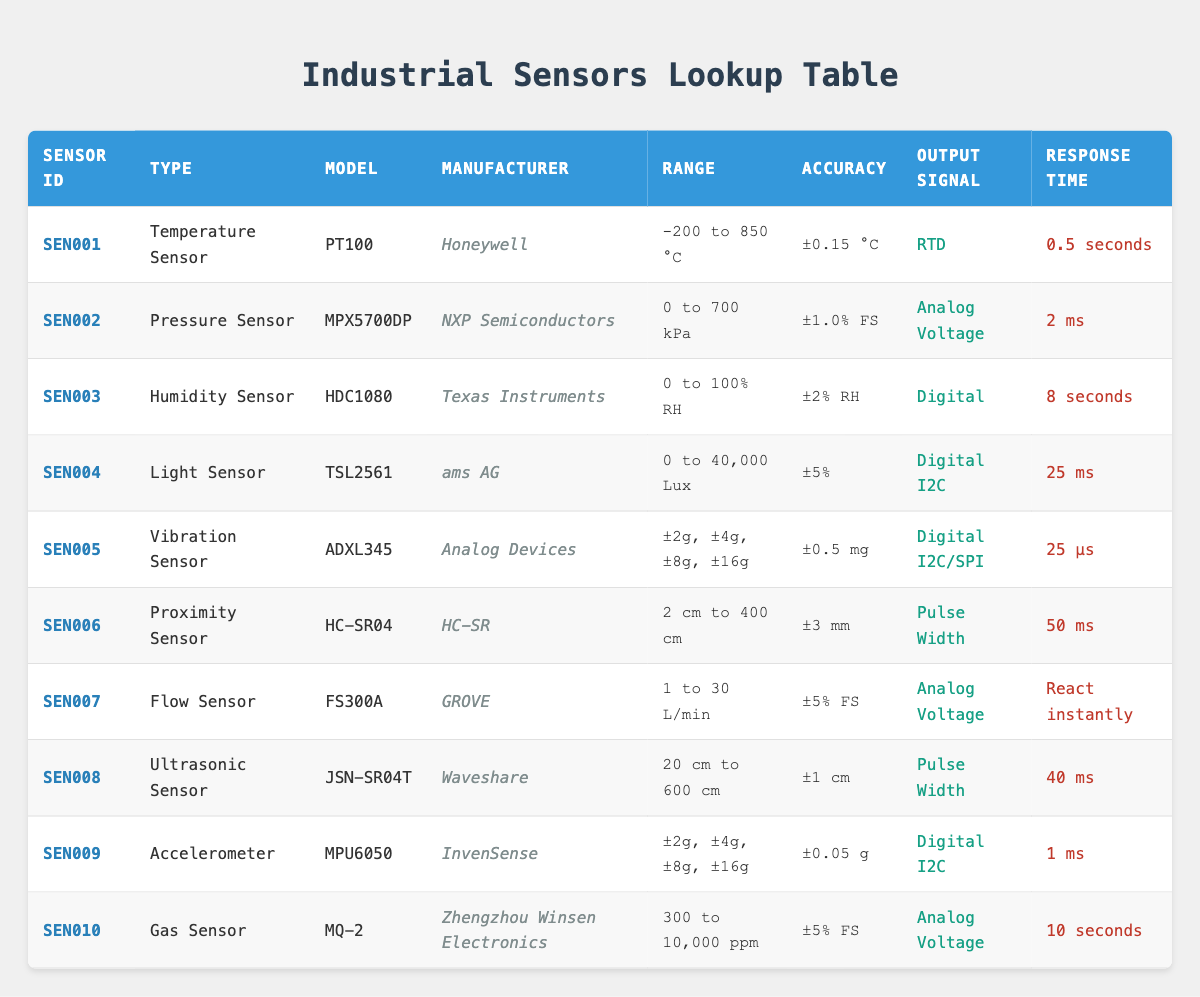What is the model of the temperature sensor? The table lists the temperature sensor under "Type" as "Temperature Sensor" and specifies the model in the column labeled "Model." Therefore, looking under that column for "SEN001," we find that the model is "PT100."
Answer: PT100 Which sensor has the highest range measured in Lux? To find out which sensor has the highest range measured in Lux, we look at the "Range" column for sensors that are light sensors. The only sensor in that category is "TSL2561," which has a range of "0 to 40,000 Lux."
Answer: TSL2561 What is the response time of the vibration sensor? The vibration sensor is listed under "SEN005." Looking across that row, we can see the "Response Time" column states it takes "25 µs."
Answer: 25 µs Do all the sensors listed have an accuracy value? We can review each row in the "Accuracy" column to see if any sensors lack an accuracy value. All listed sensors show an accuracy value, confirming that each one has this specification.
Answer: Yes What is the average range of the pressure sensor and the gas sensor in kPa and ppm? The pressure sensor (SEN002) has a range of "0 to 700 kPa," and the gas sensor (SEN010) has "300 to 10,000 ppm." To calculate average values for both, we consider the upper limits: 700 kPa and 10,000 ppm. The average range is (700 + 10000) / 2 considering only the upper limits: 5,350. The ranges technically are in different units, making their average comparison inapplicable in direct terms; this shows contrasting capabilities in measurement but does not provide a singular average.
Answer: N/A Which sensor has the fastest response time? By reviewing the "Response Time" column for all sensors, it appears that the vibration sensor (SEN005) has a response time of "25 µs" while the pressure sensor (SEN002) follows with "2 ms." Therefore, comparing the values, we see that "25 µs" is the fastest response time.
Answer: SEN005 Is the proximity sensor accurate to within ±3 mm? The proximity sensor listed as SEN006 shows its accuracy in the "Accuracy" column. It states "±3 mm," which confirms that the sensor is accurate to that specification.
Answer: Yes Which manufacturer produces the humidity sensor? The humidity sensor is listed as SEN003 in the "Type" column. Under the "Manufacturer" column for that row, the value indicates it is produced by "Texas Instruments."
Answer: Texas Instruments What is the output signal type for the flow sensor? The flow sensor (SEN007) shows its output signal type in the "Output Signal" column. It states that the output signal is "Analog Voltage."
Answer: Analog Voltage 